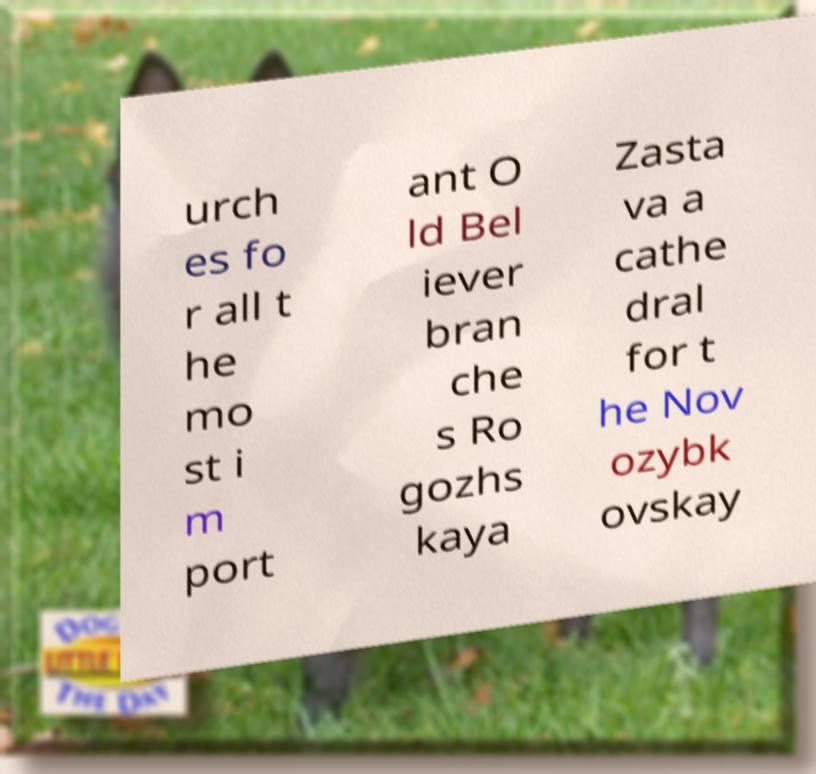What messages or text are displayed in this image? I need them in a readable, typed format. urch es fo r all t he mo st i m port ant O ld Bel iever bran che s Ro gozhs kaya Zasta va a cathe dral for t he Nov ozybk ovskay 